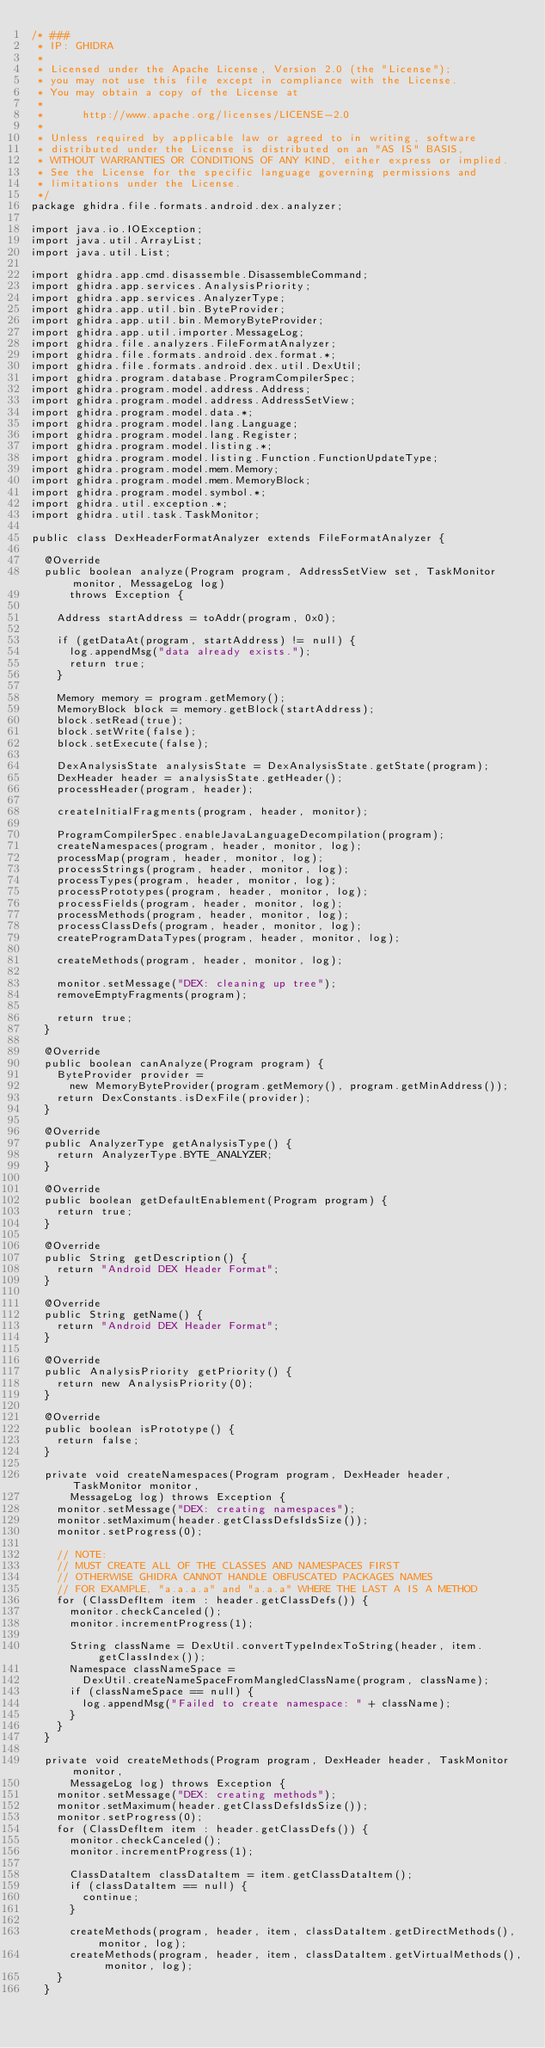Convert code to text. <code><loc_0><loc_0><loc_500><loc_500><_Java_>/* ###
 * IP: GHIDRA
 *
 * Licensed under the Apache License, Version 2.0 (the "License");
 * you may not use this file except in compliance with the License.
 * You may obtain a copy of the License at
 * 
 *      http://www.apache.org/licenses/LICENSE-2.0
 * 
 * Unless required by applicable law or agreed to in writing, software
 * distributed under the License is distributed on an "AS IS" BASIS,
 * WITHOUT WARRANTIES OR CONDITIONS OF ANY KIND, either express or implied.
 * See the License for the specific language governing permissions and
 * limitations under the License.
 */
package ghidra.file.formats.android.dex.analyzer;

import java.io.IOException;
import java.util.ArrayList;
import java.util.List;

import ghidra.app.cmd.disassemble.DisassembleCommand;
import ghidra.app.services.AnalysisPriority;
import ghidra.app.services.AnalyzerType;
import ghidra.app.util.bin.ByteProvider;
import ghidra.app.util.bin.MemoryByteProvider;
import ghidra.app.util.importer.MessageLog;
import ghidra.file.analyzers.FileFormatAnalyzer;
import ghidra.file.formats.android.dex.format.*;
import ghidra.file.formats.android.dex.util.DexUtil;
import ghidra.program.database.ProgramCompilerSpec;
import ghidra.program.model.address.Address;
import ghidra.program.model.address.AddressSetView;
import ghidra.program.model.data.*;
import ghidra.program.model.lang.Language;
import ghidra.program.model.lang.Register;
import ghidra.program.model.listing.*;
import ghidra.program.model.listing.Function.FunctionUpdateType;
import ghidra.program.model.mem.Memory;
import ghidra.program.model.mem.MemoryBlock;
import ghidra.program.model.symbol.*;
import ghidra.util.exception.*;
import ghidra.util.task.TaskMonitor;

public class DexHeaderFormatAnalyzer extends FileFormatAnalyzer {

	@Override
	public boolean analyze(Program program, AddressSetView set, TaskMonitor monitor, MessageLog log)
			throws Exception {

		Address startAddress = toAddr(program, 0x0);

		if (getDataAt(program, startAddress) != null) {
			log.appendMsg("data already exists.");
			return true;
		}

		Memory memory = program.getMemory();
		MemoryBlock block = memory.getBlock(startAddress);
		block.setRead(true);
		block.setWrite(false);
		block.setExecute(false);

		DexAnalysisState analysisState = DexAnalysisState.getState(program);
		DexHeader header = analysisState.getHeader();
		processHeader(program, header);

		createInitialFragments(program, header, monitor);

		ProgramCompilerSpec.enableJavaLanguageDecompilation(program);
		createNamespaces(program, header, monitor, log);
		processMap(program, header, monitor, log);
		processStrings(program, header, monitor, log);
		processTypes(program, header, monitor, log);
		processPrototypes(program, header, monitor, log);
		processFields(program, header, monitor, log);
		processMethods(program, header, monitor, log);
		processClassDefs(program, header, monitor, log);
		createProgramDataTypes(program, header, monitor, log);

		createMethods(program, header, monitor, log);

		monitor.setMessage("DEX: cleaning up tree");
		removeEmptyFragments(program);

		return true;
	}

	@Override
	public boolean canAnalyze(Program program) {
		ByteProvider provider =
			new MemoryByteProvider(program.getMemory(), program.getMinAddress());
		return DexConstants.isDexFile(provider);
	}

	@Override
	public AnalyzerType getAnalysisType() {
		return AnalyzerType.BYTE_ANALYZER;
	}

	@Override
	public boolean getDefaultEnablement(Program program) {
		return true;
	}

	@Override
	public String getDescription() {
		return "Android DEX Header Format";
	}

	@Override
	public String getName() {
		return "Android DEX Header Format";
	}

	@Override
	public AnalysisPriority getPriority() {
		return new AnalysisPriority(0);
	}

	@Override
	public boolean isPrototype() {
		return false;
	}

	private void createNamespaces(Program program, DexHeader header, TaskMonitor monitor,
			MessageLog log) throws Exception {
		monitor.setMessage("DEX: creating namespaces");
		monitor.setMaximum(header.getClassDefsIdsSize());
		monitor.setProgress(0);

		// NOTE:
		// MUST CREATE ALL OF THE CLASSES AND NAMESPACES FIRST
		// OTHERWISE GHIDRA CANNOT HANDLE OBFUSCATED PACKAGES NAMES
		// FOR EXAMPLE, "a.a.a.a" and "a.a.a" WHERE THE LAST A IS A METHOD
		for (ClassDefItem item : header.getClassDefs()) {
			monitor.checkCanceled();
			monitor.incrementProgress(1);

			String className = DexUtil.convertTypeIndexToString(header, item.getClassIndex());
			Namespace classNameSpace =
				DexUtil.createNameSpaceFromMangledClassName(program, className);
			if (classNameSpace == null) {
				log.appendMsg("Failed to create namespace: " + className);
			}
		}
	}

	private void createMethods(Program program, DexHeader header, TaskMonitor monitor,
			MessageLog log) throws Exception {
		monitor.setMessage("DEX: creating methods");
		monitor.setMaximum(header.getClassDefsIdsSize());
		monitor.setProgress(0);
		for (ClassDefItem item : header.getClassDefs()) {
			monitor.checkCanceled();
			monitor.incrementProgress(1);

			ClassDataItem classDataItem = item.getClassDataItem();
			if (classDataItem == null) {
				continue;
			}

			createMethods(program, header, item, classDataItem.getDirectMethods(), monitor, log);
			createMethods(program, header, item, classDataItem.getVirtualMethods(), monitor, log);
		}
	}
</code> 